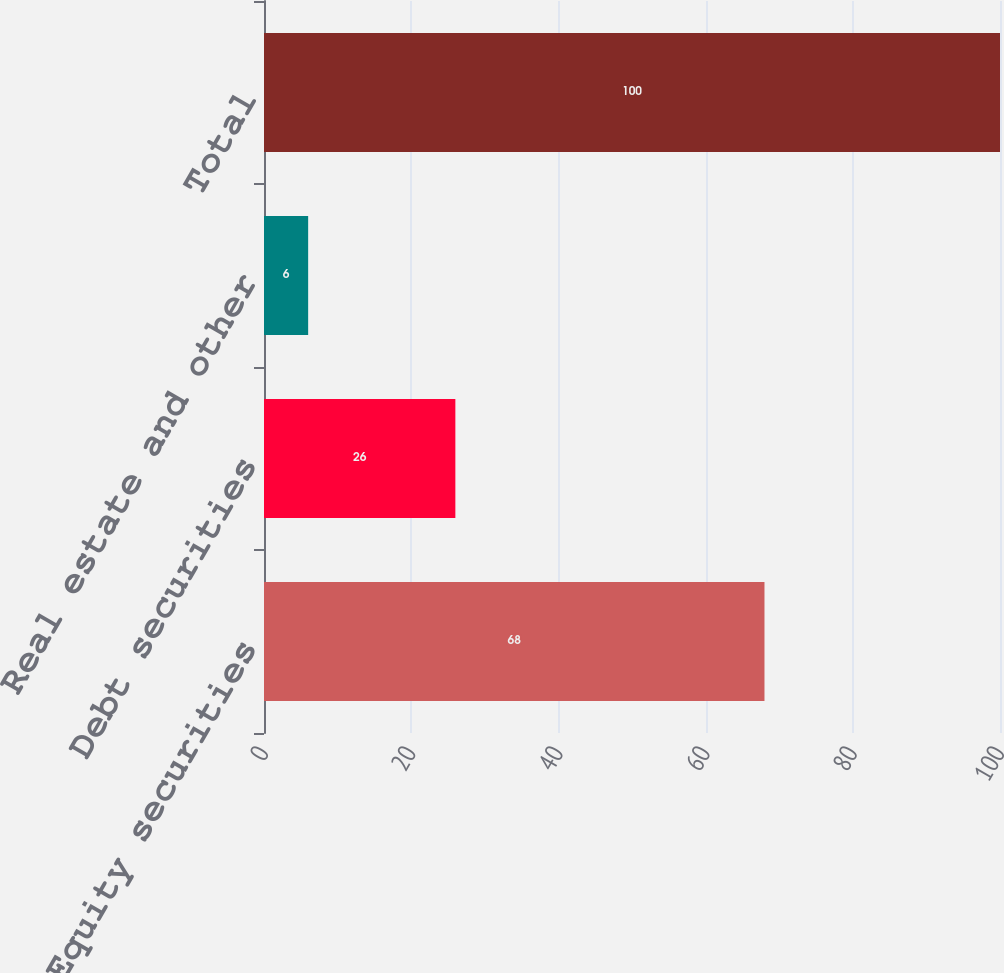<chart> <loc_0><loc_0><loc_500><loc_500><bar_chart><fcel>Equity securities<fcel>Debt securities<fcel>Real estate and other<fcel>Total<nl><fcel>68<fcel>26<fcel>6<fcel>100<nl></chart> 